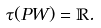Convert formula to latex. <formula><loc_0><loc_0><loc_500><loc_500>\tau ( P W ) = { \mathbb { R } } .</formula> 